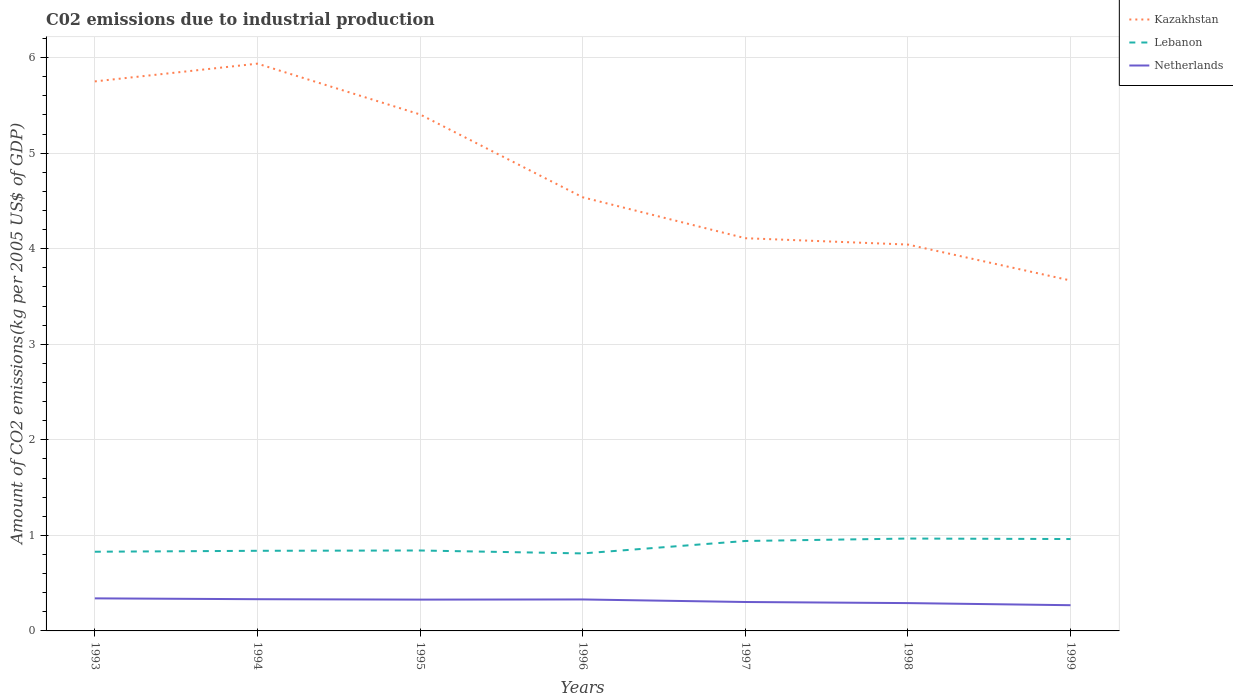How many different coloured lines are there?
Offer a terse response. 3. Does the line corresponding to Lebanon intersect with the line corresponding to Netherlands?
Keep it short and to the point. No. Across all years, what is the maximum amount of CO2 emitted due to industrial production in Lebanon?
Your response must be concise. 0.81. In which year was the amount of CO2 emitted due to industrial production in Kazakhstan maximum?
Your response must be concise. 1999. What is the total amount of CO2 emitted due to industrial production in Lebanon in the graph?
Provide a succinct answer. -0.13. What is the difference between the highest and the second highest amount of CO2 emitted due to industrial production in Lebanon?
Your answer should be compact. 0.16. Are the values on the major ticks of Y-axis written in scientific E-notation?
Provide a short and direct response. No. Does the graph contain any zero values?
Provide a short and direct response. No. Where does the legend appear in the graph?
Make the answer very short. Top right. How many legend labels are there?
Provide a short and direct response. 3. What is the title of the graph?
Your response must be concise. C02 emissions due to industrial production. What is the label or title of the Y-axis?
Offer a very short reply. Amount of CO2 emissions(kg per 2005 US$ of GDP). What is the Amount of CO2 emissions(kg per 2005 US$ of GDP) of Kazakhstan in 1993?
Make the answer very short. 5.75. What is the Amount of CO2 emissions(kg per 2005 US$ of GDP) of Lebanon in 1993?
Offer a terse response. 0.83. What is the Amount of CO2 emissions(kg per 2005 US$ of GDP) in Netherlands in 1993?
Keep it short and to the point. 0.34. What is the Amount of CO2 emissions(kg per 2005 US$ of GDP) in Kazakhstan in 1994?
Provide a short and direct response. 5.94. What is the Amount of CO2 emissions(kg per 2005 US$ of GDP) of Lebanon in 1994?
Offer a very short reply. 0.84. What is the Amount of CO2 emissions(kg per 2005 US$ of GDP) in Netherlands in 1994?
Keep it short and to the point. 0.33. What is the Amount of CO2 emissions(kg per 2005 US$ of GDP) in Kazakhstan in 1995?
Your answer should be very brief. 5.4. What is the Amount of CO2 emissions(kg per 2005 US$ of GDP) in Lebanon in 1995?
Your answer should be compact. 0.84. What is the Amount of CO2 emissions(kg per 2005 US$ of GDP) of Netherlands in 1995?
Give a very brief answer. 0.33. What is the Amount of CO2 emissions(kg per 2005 US$ of GDP) of Kazakhstan in 1996?
Your answer should be compact. 4.54. What is the Amount of CO2 emissions(kg per 2005 US$ of GDP) in Lebanon in 1996?
Give a very brief answer. 0.81. What is the Amount of CO2 emissions(kg per 2005 US$ of GDP) of Netherlands in 1996?
Make the answer very short. 0.33. What is the Amount of CO2 emissions(kg per 2005 US$ of GDP) in Kazakhstan in 1997?
Your answer should be compact. 4.11. What is the Amount of CO2 emissions(kg per 2005 US$ of GDP) in Lebanon in 1997?
Provide a succinct answer. 0.94. What is the Amount of CO2 emissions(kg per 2005 US$ of GDP) of Netherlands in 1997?
Make the answer very short. 0.3. What is the Amount of CO2 emissions(kg per 2005 US$ of GDP) in Kazakhstan in 1998?
Your response must be concise. 4.04. What is the Amount of CO2 emissions(kg per 2005 US$ of GDP) in Lebanon in 1998?
Provide a short and direct response. 0.97. What is the Amount of CO2 emissions(kg per 2005 US$ of GDP) of Netherlands in 1998?
Provide a short and direct response. 0.29. What is the Amount of CO2 emissions(kg per 2005 US$ of GDP) in Kazakhstan in 1999?
Give a very brief answer. 3.67. What is the Amount of CO2 emissions(kg per 2005 US$ of GDP) of Lebanon in 1999?
Your answer should be very brief. 0.96. What is the Amount of CO2 emissions(kg per 2005 US$ of GDP) in Netherlands in 1999?
Your answer should be compact. 0.27. Across all years, what is the maximum Amount of CO2 emissions(kg per 2005 US$ of GDP) in Kazakhstan?
Provide a short and direct response. 5.94. Across all years, what is the maximum Amount of CO2 emissions(kg per 2005 US$ of GDP) of Lebanon?
Your answer should be very brief. 0.97. Across all years, what is the maximum Amount of CO2 emissions(kg per 2005 US$ of GDP) of Netherlands?
Provide a succinct answer. 0.34. Across all years, what is the minimum Amount of CO2 emissions(kg per 2005 US$ of GDP) in Kazakhstan?
Your response must be concise. 3.67. Across all years, what is the minimum Amount of CO2 emissions(kg per 2005 US$ of GDP) in Lebanon?
Your answer should be compact. 0.81. Across all years, what is the minimum Amount of CO2 emissions(kg per 2005 US$ of GDP) of Netherlands?
Your answer should be compact. 0.27. What is the total Amount of CO2 emissions(kg per 2005 US$ of GDP) of Kazakhstan in the graph?
Your response must be concise. 33.45. What is the total Amount of CO2 emissions(kg per 2005 US$ of GDP) of Lebanon in the graph?
Provide a succinct answer. 6.19. What is the total Amount of CO2 emissions(kg per 2005 US$ of GDP) of Netherlands in the graph?
Give a very brief answer. 2.19. What is the difference between the Amount of CO2 emissions(kg per 2005 US$ of GDP) of Kazakhstan in 1993 and that in 1994?
Provide a short and direct response. -0.19. What is the difference between the Amount of CO2 emissions(kg per 2005 US$ of GDP) in Lebanon in 1993 and that in 1994?
Provide a succinct answer. -0.01. What is the difference between the Amount of CO2 emissions(kg per 2005 US$ of GDP) in Netherlands in 1993 and that in 1994?
Keep it short and to the point. 0.01. What is the difference between the Amount of CO2 emissions(kg per 2005 US$ of GDP) in Kazakhstan in 1993 and that in 1995?
Provide a short and direct response. 0.35. What is the difference between the Amount of CO2 emissions(kg per 2005 US$ of GDP) in Lebanon in 1993 and that in 1995?
Provide a short and direct response. -0.01. What is the difference between the Amount of CO2 emissions(kg per 2005 US$ of GDP) in Netherlands in 1993 and that in 1995?
Keep it short and to the point. 0.01. What is the difference between the Amount of CO2 emissions(kg per 2005 US$ of GDP) of Kazakhstan in 1993 and that in 1996?
Your answer should be very brief. 1.21. What is the difference between the Amount of CO2 emissions(kg per 2005 US$ of GDP) of Lebanon in 1993 and that in 1996?
Provide a succinct answer. 0.02. What is the difference between the Amount of CO2 emissions(kg per 2005 US$ of GDP) of Netherlands in 1993 and that in 1996?
Make the answer very short. 0.01. What is the difference between the Amount of CO2 emissions(kg per 2005 US$ of GDP) in Kazakhstan in 1993 and that in 1997?
Make the answer very short. 1.64. What is the difference between the Amount of CO2 emissions(kg per 2005 US$ of GDP) in Lebanon in 1993 and that in 1997?
Provide a short and direct response. -0.11. What is the difference between the Amount of CO2 emissions(kg per 2005 US$ of GDP) in Netherlands in 1993 and that in 1997?
Your response must be concise. 0.04. What is the difference between the Amount of CO2 emissions(kg per 2005 US$ of GDP) in Kazakhstan in 1993 and that in 1998?
Your answer should be very brief. 1.71. What is the difference between the Amount of CO2 emissions(kg per 2005 US$ of GDP) in Lebanon in 1993 and that in 1998?
Make the answer very short. -0.14. What is the difference between the Amount of CO2 emissions(kg per 2005 US$ of GDP) in Netherlands in 1993 and that in 1998?
Offer a terse response. 0.05. What is the difference between the Amount of CO2 emissions(kg per 2005 US$ of GDP) in Kazakhstan in 1993 and that in 1999?
Keep it short and to the point. 2.08. What is the difference between the Amount of CO2 emissions(kg per 2005 US$ of GDP) of Lebanon in 1993 and that in 1999?
Provide a short and direct response. -0.13. What is the difference between the Amount of CO2 emissions(kg per 2005 US$ of GDP) in Netherlands in 1993 and that in 1999?
Provide a succinct answer. 0.07. What is the difference between the Amount of CO2 emissions(kg per 2005 US$ of GDP) in Kazakhstan in 1994 and that in 1995?
Your answer should be compact. 0.53. What is the difference between the Amount of CO2 emissions(kg per 2005 US$ of GDP) in Lebanon in 1994 and that in 1995?
Your answer should be compact. -0. What is the difference between the Amount of CO2 emissions(kg per 2005 US$ of GDP) of Netherlands in 1994 and that in 1995?
Make the answer very short. 0. What is the difference between the Amount of CO2 emissions(kg per 2005 US$ of GDP) of Kazakhstan in 1994 and that in 1996?
Your answer should be very brief. 1.4. What is the difference between the Amount of CO2 emissions(kg per 2005 US$ of GDP) in Lebanon in 1994 and that in 1996?
Offer a terse response. 0.03. What is the difference between the Amount of CO2 emissions(kg per 2005 US$ of GDP) in Netherlands in 1994 and that in 1996?
Make the answer very short. 0. What is the difference between the Amount of CO2 emissions(kg per 2005 US$ of GDP) of Kazakhstan in 1994 and that in 1997?
Your answer should be compact. 1.83. What is the difference between the Amount of CO2 emissions(kg per 2005 US$ of GDP) in Lebanon in 1994 and that in 1997?
Provide a succinct answer. -0.1. What is the difference between the Amount of CO2 emissions(kg per 2005 US$ of GDP) of Netherlands in 1994 and that in 1997?
Your answer should be very brief. 0.03. What is the difference between the Amount of CO2 emissions(kg per 2005 US$ of GDP) in Kazakhstan in 1994 and that in 1998?
Give a very brief answer. 1.89. What is the difference between the Amount of CO2 emissions(kg per 2005 US$ of GDP) in Lebanon in 1994 and that in 1998?
Give a very brief answer. -0.13. What is the difference between the Amount of CO2 emissions(kg per 2005 US$ of GDP) in Netherlands in 1994 and that in 1998?
Provide a succinct answer. 0.04. What is the difference between the Amount of CO2 emissions(kg per 2005 US$ of GDP) in Kazakhstan in 1994 and that in 1999?
Your response must be concise. 2.27. What is the difference between the Amount of CO2 emissions(kg per 2005 US$ of GDP) of Lebanon in 1994 and that in 1999?
Ensure brevity in your answer.  -0.12. What is the difference between the Amount of CO2 emissions(kg per 2005 US$ of GDP) in Netherlands in 1994 and that in 1999?
Make the answer very short. 0.06. What is the difference between the Amount of CO2 emissions(kg per 2005 US$ of GDP) of Kazakhstan in 1995 and that in 1996?
Offer a very short reply. 0.87. What is the difference between the Amount of CO2 emissions(kg per 2005 US$ of GDP) of Lebanon in 1995 and that in 1996?
Provide a succinct answer. 0.03. What is the difference between the Amount of CO2 emissions(kg per 2005 US$ of GDP) in Netherlands in 1995 and that in 1996?
Provide a short and direct response. -0. What is the difference between the Amount of CO2 emissions(kg per 2005 US$ of GDP) of Kazakhstan in 1995 and that in 1997?
Ensure brevity in your answer.  1.29. What is the difference between the Amount of CO2 emissions(kg per 2005 US$ of GDP) of Lebanon in 1995 and that in 1997?
Offer a very short reply. -0.1. What is the difference between the Amount of CO2 emissions(kg per 2005 US$ of GDP) in Netherlands in 1995 and that in 1997?
Provide a short and direct response. 0.03. What is the difference between the Amount of CO2 emissions(kg per 2005 US$ of GDP) of Kazakhstan in 1995 and that in 1998?
Give a very brief answer. 1.36. What is the difference between the Amount of CO2 emissions(kg per 2005 US$ of GDP) in Lebanon in 1995 and that in 1998?
Make the answer very short. -0.12. What is the difference between the Amount of CO2 emissions(kg per 2005 US$ of GDP) of Netherlands in 1995 and that in 1998?
Your answer should be very brief. 0.04. What is the difference between the Amount of CO2 emissions(kg per 2005 US$ of GDP) of Kazakhstan in 1995 and that in 1999?
Keep it short and to the point. 1.74. What is the difference between the Amount of CO2 emissions(kg per 2005 US$ of GDP) in Lebanon in 1995 and that in 1999?
Offer a very short reply. -0.12. What is the difference between the Amount of CO2 emissions(kg per 2005 US$ of GDP) of Netherlands in 1995 and that in 1999?
Make the answer very short. 0.06. What is the difference between the Amount of CO2 emissions(kg per 2005 US$ of GDP) of Kazakhstan in 1996 and that in 1997?
Your response must be concise. 0.43. What is the difference between the Amount of CO2 emissions(kg per 2005 US$ of GDP) of Lebanon in 1996 and that in 1997?
Offer a terse response. -0.13. What is the difference between the Amount of CO2 emissions(kg per 2005 US$ of GDP) of Netherlands in 1996 and that in 1997?
Your answer should be very brief. 0.03. What is the difference between the Amount of CO2 emissions(kg per 2005 US$ of GDP) in Kazakhstan in 1996 and that in 1998?
Your response must be concise. 0.49. What is the difference between the Amount of CO2 emissions(kg per 2005 US$ of GDP) in Lebanon in 1996 and that in 1998?
Provide a short and direct response. -0.16. What is the difference between the Amount of CO2 emissions(kg per 2005 US$ of GDP) of Netherlands in 1996 and that in 1998?
Ensure brevity in your answer.  0.04. What is the difference between the Amount of CO2 emissions(kg per 2005 US$ of GDP) of Kazakhstan in 1996 and that in 1999?
Your answer should be compact. 0.87. What is the difference between the Amount of CO2 emissions(kg per 2005 US$ of GDP) in Lebanon in 1996 and that in 1999?
Make the answer very short. -0.15. What is the difference between the Amount of CO2 emissions(kg per 2005 US$ of GDP) in Netherlands in 1996 and that in 1999?
Keep it short and to the point. 0.06. What is the difference between the Amount of CO2 emissions(kg per 2005 US$ of GDP) of Kazakhstan in 1997 and that in 1998?
Ensure brevity in your answer.  0.07. What is the difference between the Amount of CO2 emissions(kg per 2005 US$ of GDP) of Lebanon in 1997 and that in 1998?
Ensure brevity in your answer.  -0.03. What is the difference between the Amount of CO2 emissions(kg per 2005 US$ of GDP) of Netherlands in 1997 and that in 1998?
Keep it short and to the point. 0.01. What is the difference between the Amount of CO2 emissions(kg per 2005 US$ of GDP) in Kazakhstan in 1997 and that in 1999?
Provide a succinct answer. 0.44. What is the difference between the Amount of CO2 emissions(kg per 2005 US$ of GDP) in Lebanon in 1997 and that in 1999?
Offer a very short reply. -0.02. What is the difference between the Amount of CO2 emissions(kg per 2005 US$ of GDP) in Netherlands in 1997 and that in 1999?
Offer a terse response. 0.03. What is the difference between the Amount of CO2 emissions(kg per 2005 US$ of GDP) in Kazakhstan in 1998 and that in 1999?
Offer a terse response. 0.38. What is the difference between the Amount of CO2 emissions(kg per 2005 US$ of GDP) in Lebanon in 1998 and that in 1999?
Make the answer very short. 0.01. What is the difference between the Amount of CO2 emissions(kg per 2005 US$ of GDP) in Netherlands in 1998 and that in 1999?
Offer a terse response. 0.02. What is the difference between the Amount of CO2 emissions(kg per 2005 US$ of GDP) of Kazakhstan in 1993 and the Amount of CO2 emissions(kg per 2005 US$ of GDP) of Lebanon in 1994?
Your answer should be very brief. 4.91. What is the difference between the Amount of CO2 emissions(kg per 2005 US$ of GDP) of Kazakhstan in 1993 and the Amount of CO2 emissions(kg per 2005 US$ of GDP) of Netherlands in 1994?
Provide a succinct answer. 5.42. What is the difference between the Amount of CO2 emissions(kg per 2005 US$ of GDP) in Lebanon in 1993 and the Amount of CO2 emissions(kg per 2005 US$ of GDP) in Netherlands in 1994?
Your answer should be very brief. 0.5. What is the difference between the Amount of CO2 emissions(kg per 2005 US$ of GDP) in Kazakhstan in 1993 and the Amount of CO2 emissions(kg per 2005 US$ of GDP) in Lebanon in 1995?
Your answer should be very brief. 4.91. What is the difference between the Amount of CO2 emissions(kg per 2005 US$ of GDP) of Kazakhstan in 1993 and the Amount of CO2 emissions(kg per 2005 US$ of GDP) of Netherlands in 1995?
Provide a short and direct response. 5.42. What is the difference between the Amount of CO2 emissions(kg per 2005 US$ of GDP) of Lebanon in 1993 and the Amount of CO2 emissions(kg per 2005 US$ of GDP) of Netherlands in 1995?
Keep it short and to the point. 0.5. What is the difference between the Amount of CO2 emissions(kg per 2005 US$ of GDP) of Kazakhstan in 1993 and the Amount of CO2 emissions(kg per 2005 US$ of GDP) of Lebanon in 1996?
Your answer should be compact. 4.94. What is the difference between the Amount of CO2 emissions(kg per 2005 US$ of GDP) of Kazakhstan in 1993 and the Amount of CO2 emissions(kg per 2005 US$ of GDP) of Netherlands in 1996?
Make the answer very short. 5.42. What is the difference between the Amount of CO2 emissions(kg per 2005 US$ of GDP) of Lebanon in 1993 and the Amount of CO2 emissions(kg per 2005 US$ of GDP) of Netherlands in 1996?
Give a very brief answer. 0.5. What is the difference between the Amount of CO2 emissions(kg per 2005 US$ of GDP) in Kazakhstan in 1993 and the Amount of CO2 emissions(kg per 2005 US$ of GDP) in Lebanon in 1997?
Keep it short and to the point. 4.81. What is the difference between the Amount of CO2 emissions(kg per 2005 US$ of GDP) of Kazakhstan in 1993 and the Amount of CO2 emissions(kg per 2005 US$ of GDP) of Netherlands in 1997?
Provide a short and direct response. 5.45. What is the difference between the Amount of CO2 emissions(kg per 2005 US$ of GDP) of Lebanon in 1993 and the Amount of CO2 emissions(kg per 2005 US$ of GDP) of Netherlands in 1997?
Keep it short and to the point. 0.53. What is the difference between the Amount of CO2 emissions(kg per 2005 US$ of GDP) in Kazakhstan in 1993 and the Amount of CO2 emissions(kg per 2005 US$ of GDP) in Lebanon in 1998?
Your response must be concise. 4.78. What is the difference between the Amount of CO2 emissions(kg per 2005 US$ of GDP) of Kazakhstan in 1993 and the Amount of CO2 emissions(kg per 2005 US$ of GDP) of Netherlands in 1998?
Give a very brief answer. 5.46. What is the difference between the Amount of CO2 emissions(kg per 2005 US$ of GDP) of Lebanon in 1993 and the Amount of CO2 emissions(kg per 2005 US$ of GDP) of Netherlands in 1998?
Provide a short and direct response. 0.54. What is the difference between the Amount of CO2 emissions(kg per 2005 US$ of GDP) in Kazakhstan in 1993 and the Amount of CO2 emissions(kg per 2005 US$ of GDP) in Lebanon in 1999?
Keep it short and to the point. 4.79. What is the difference between the Amount of CO2 emissions(kg per 2005 US$ of GDP) of Kazakhstan in 1993 and the Amount of CO2 emissions(kg per 2005 US$ of GDP) of Netherlands in 1999?
Offer a terse response. 5.48. What is the difference between the Amount of CO2 emissions(kg per 2005 US$ of GDP) of Lebanon in 1993 and the Amount of CO2 emissions(kg per 2005 US$ of GDP) of Netherlands in 1999?
Your answer should be compact. 0.56. What is the difference between the Amount of CO2 emissions(kg per 2005 US$ of GDP) in Kazakhstan in 1994 and the Amount of CO2 emissions(kg per 2005 US$ of GDP) in Lebanon in 1995?
Your answer should be very brief. 5.09. What is the difference between the Amount of CO2 emissions(kg per 2005 US$ of GDP) of Kazakhstan in 1994 and the Amount of CO2 emissions(kg per 2005 US$ of GDP) of Netherlands in 1995?
Your answer should be very brief. 5.61. What is the difference between the Amount of CO2 emissions(kg per 2005 US$ of GDP) of Lebanon in 1994 and the Amount of CO2 emissions(kg per 2005 US$ of GDP) of Netherlands in 1995?
Give a very brief answer. 0.51. What is the difference between the Amount of CO2 emissions(kg per 2005 US$ of GDP) of Kazakhstan in 1994 and the Amount of CO2 emissions(kg per 2005 US$ of GDP) of Lebanon in 1996?
Offer a terse response. 5.13. What is the difference between the Amount of CO2 emissions(kg per 2005 US$ of GDP) in Kazakhstan in 1994 and the Amount of CO2 emissions(kg per 2005 US$ of GDP) in Netherlands in 1996?
Keep it short and to the point. 5.61. What is the difference between the Amount of CO2 emissions(kg per 2005 US$ of GDP) of Lebanon in 1994 and the Amount of CO2 emissions(kg per 2005 US$ of GDP) of Netherlands in 1996?
Ensure brevity in your answer.  0.51. What is the difference between the Amount of CO2 emissions(kg per 2005 US$ of GDP) in Kazakhstan in 1994 and the Amount of CO2 emissions(kg per 2005 US$ of GDP) in Lebanon in 1997?
Ensure brevity in your answer.  5. What is the difference between the Amount of CO2 emissions(kg per 2005 US$ of GDP) of Kazakhstan in 1994 and the Amount of CO2 emissions(kg per 2005 US$ of GDP) of Netherlands in 1997?
Provide a short and direct response. 5.63. What is the difference between the Amount of CO2 emissions(kg per 2005 US$ of GDP) of Lebanon in 1994 and the Amount of CO2 emissions(kg per 2005 US$ of GDP) of Netherlands in 1997?
Give a very brief answer. 0.54. What is the difference between the Amount of CO2 emissions(kg per 2005 US$ of GDP) of Kazakhstan in 1994 and the Amount of CO2 emissions(kg per 2005 US$ of GDP) of Lebanon in 1998?
Give a very brief answer. 4.97. What is the difference between the Amount of CO2 emissions(kg per 2005 US$ of GDP) in Kazakhstan in 1994 and the Amount of CO2 emissions(kg per 2005 US$ of GDP) in Netherlands in 1998?
Give a very brief answer. 5.65. What is the difference between the Amount of CO2 emissions(kg per 2005 US$ of GDP) in Lebanon in 1994 and the Amount of CO2 emissions(kg per 2005 US$ of GDP) in Netherlands in 1998?
Your answer should be compact. 0.55. What is the difference between the Amount of CO2 emissions(kg per 2005 US$ of GDP) in Kazakhstan in 1994 and the Amount of CO2 emissions(kg per 2005 US$ of GDP) in Lebanon in 1999?
Your answer should be compact. 4.97. What is the difference between the Amount of CO2 emissions(kg per 2005 US$ of GDP) of Kazakhstan in 1994 and the Amount of CO2 emissions(kg per 2005 US$ of GDP) of Netherlands in 1999?
Provide a succinct answer. 5.67. What is the difference between the Amount of CO2 emissions(kg per 2005 US$ of GDP) in Lebanon in 1994 and the Amount of CO2 emissions(kg per 2005 US$ of GDP) in Netherlands in 1999?
Your answer should be very brief. 0.57. What is the difference between the Amount of CO2 emissions(kg per 2005 US$ of GDP) in Kazakhstan in 1995 and the Amount of CO2 emissions(kg per 2005 US$ of GDP) in Lebanon in 1996?
Provide a succinct answer. 4.59. What is the difference between the Amount of CO2 emissions(kg per 2005 US$ of GDP) of Kazakhstan in 1995 and the Amount of CO2 emissions(kg per 2005 US$ of GDP) of Netherlands in 1996?
Your answer should be compact. 5.08. What is the difference between the Amount of CO2 emissions(kg per 2005 US$ of GDP) in Lebanon in 1995 and the Amount of CO2 emissions(kg per 2005 US$ of GDP) in Netherlands in 1996?
Ensure brevity in your answer.  0.51. What is the difference between the Amount of CO2 emissions(kg per 2005 US$ of GDP) in Kazakhstan in 1995 and the Amount of CO2 emissions(kg per 2005 US$ of GDP) in Lebanon in 1997?
Offer a terse response. 4.46. What is the difference between the Amount of CO2 emissions(kg per 2005 US$ of GDP) in Kazakhstan in 1995 and the Amount of CO2 emissions(kg per 2005 US$ of GDP) in Netherlands in 1997?
Make the answer very short. 5.1. What is the difference between the Amount of CO2 emissions(kg per 2005 US$ of GDP) in Lebanon in 1995 and the Amount of CO2 emissions(kg per 2005 US$ of GDP) in Netherlands in 1997?
Ensure brevity in your answer.  0.54. What is the difference between the Amount of CO2 emissions(kg per 2005 US$ of GDP) in Kazakhstan in 1995 and the Amount of CO2 emissions(kg per 2005 US$ of GDP) in Lebanon in 1998?
Provide a short and direct response. 4.44. What is the difference between the Amount of CO2 emissions(kg per 2005 US$ of GDP) of Kazakhstan in 1995 and the Amount of CO2 emissions(kg per 2005 US$ of GDP) of Netherlands in 1998?
Make the answer very short. 5.11. What is the difference between the Amount of CO2 emissions(kg per 2005 US$ of GDP) in Lebanon in 1995 and the Amount of CO2 emissions(kg per 2005 US$ of GDP) in Netherlands in 1998?
Your response must be concise. 0.55. What is the difference between the Amount of CO2 emissions(kg per 2005 US$ of GDP) of Kazakhstan in 1995 and the Amount of CO2 emissions(kg per 2005 US$ of GDP) of Lebanon in 1999?
Make the answer very short. 4.44. What is the difference between the Amount of CO2 emissions(kg per 2005 US$ of GDP) of Kazakhstan in 1995 and the Amount of CO2 emissions(kg per 2005 US$ of GDP) of Netherlands in 1999?
Your answer should be compact. 5.14. What is the difference between the Amount of CO2 emissions(kg per 2005 US$ of GDP) of Lebanon in 1995 and the Amount of CO2 emissions(kg per 2005 US$ of GDP) of Netherlands in 1999?
Offer a very short reply. 0.57. What is the difference between the Amount of CO2 emissions(kg per 2005 US$ of GDP) in Kazakhstan in 1996 and the Amount of CO2 emissions(kg per 2005 US$ of GDP) in Lebanon in 1997?
Your response must be concise. 3.6. What is the difference between the Amount of CO2 emissions(kg per 2005 US$ of GDP) in Kazakhstan in 1996 and the Amount of CO2 emissions(kg per 2005 US$ of GDP) in Netherlands in 1997?
Your response must be concise. 4.24. What is the difference between the Amount of CO2 emissions(kg per 2005 US$ of GDP) in Lebanon in 1996 and the Amount of CO2 emissions(kg per 2005 US$ of GDP) in Netherlands in 1997?
Ensure brevity in your answer.  0.51. What is the difference between the Amount of CO2 emissions(kg per 2005 US$ of GDP) of Kazakhstan in 1996 and the Amount of CO2 emissions(kg per 2005 US$ of GDP) of Lebanon in 1998?
Keep it short and to the point. 3.57. What is the difference between the Amount of CO2 emissions(kg per 2005 US$ of GDP) of Kazakhstan in 1996 and the Amount of CO2 emissions(kg per 2005 US$ of GDP) of Netherlands in 1998?
Provide a short and direct response. 4.25. What is the difference between the Amount of CO2 emissions(kg per 2005 US$ of GDP) of Lebanon in 1996 and the Amount of CO2 emissions(kg per 2005 US$ of GDP) of Netherlands in 1998?
Your answer should be very brief. 0.52. What is the difference between the Amount of CO2 emissions(kg per 2005 US$ of GDP) in Kazakhstan in 1996 and the Amount of CO2 emissions(kg per 2005 US$ of GDP) in Lebanon in 1999?
Ensure brevity in your answer.  3.58. What is the difference between the Amount of CO2 emissions(kg per 2005 US$ of GDP) in Kazakhstan in 1996 and the Amount of CO2 emissions(kg per 2005 US$ of GDP) in Netherlands in 1999?
Ensure brevity in your answer.  4.27. What is the difference between the Amount of CO2 emissions(kg per 2005 US$ of GDP) of Lebanon in 1996 and the Amount of CO2 emissions(kg per 2005 US$ of GDP) of Netherlands in 1999?
Your answer should be compact. 0.54. What is the difference between the Amount of CO2 emissions(kg per 2005 US$ of GDP) of Kazakhstan in 1997 and the Amount of CO2 emissions(kg per 2005 US$ of GDP) of Lebanon in 1998?
Your answer should be compact. 3.14. What is the difference between the Amount of CO2 emissions(kg per 2005 US$ of GDP) of Kazakhstan in 1997 and the Amount of CO2 emissions(kg per 2005 US$ of GDP) of Netherlands in 1998?
Give a very brief answer. 3.82. What is the difference between the Amount of CO2 emissions(kg per 2005 US$ of GDP) of Lebanon in 1997 and the Amount of CO2 emissions(kg per 2005 US$ of GDP) of Netherlands in 1998?
Your response must be concise. 0.65. What is the difference between the Amount of CO2 emissions(kg per 2005 US$ of GDP) of Kazakhstan in 1997 and the Amount of CO2 emissions(kg per 2005 US$ of GDP) of Lebanon in 1999?
Your response must be concise. 3.15. What is the difference between the Amount of CO2 emissions(kg per 2005 US$ of GDP) in Kazakhstan in 1997 and the Amount of CO2 emissions(kg per 2005 US$ of GDP) in Netherlands in 1999?
Ensure brevity in your answer.  3.84. What is the difference between the Amount of CO2 emissions(kg per 2005 US$ of GDP) of Lebanon in 1997 and the Amount of CO2 emissions(kg per 2005 US$ of GDP) of Netherlands in 1999?
Give a very brief answer. 0.67. What is the difference between the Amount of CO2 emissions(kg per 2005 US$ of GDP) in Kazakhstan in 1998 and the Amount of CO2 emissions(kg per 2005 US$ of GDP) in Lebanon in 1999?
Ensure brevity in your answer.  3.08. What is the difference between the Amount of CO2 emissions(kg per 2005 US$ of GDP) in Kazakhstan in 1998 and the Amount of CO2 emissions(kg per 2005 US$ of GDP) in Netherlands in 1999?
Ensure brevity in your answer.  3.77. What is the difference between the Amount of CO2 emissions(kg per 2005 US$ of GDP) in Lebanon in 1998 and the Amount of CO2 emissions(kg per 2005 US$ of GDP) in Netherlands in 1999?
Keep it short and to the point. 0.7. What is the average Amount of CO2 emissions(kg per 2005 US$ of GDP) of Kazakhstan per year?
Your answer should be very brief. 4.78. What is the average Amount of CO2 emissions(kg per 2005 US$ of GDP) in Lebanon per year?
Ensure brevity in your answer.  0.88. What is the average Amount of CO2 emissions(kg per 2005 US$ of GDP) in Netherlands per year?
Ensure brevity in your answer.  0.31. In the year 1993, what is the difference between the Amount of CO2 emissions(kg per 2005 US$ of GDP) in Kazakhstan and Amount of CO2 emissions(kg per 2005 US$ of GDP) in Lebanon?
Your answer should be compact. 4.92. In the year 1993, what is the difference between the Amount of CO2 emissions(kg per 2005 US$ of GDP) in Kazakhstan and Amount of CO2 emissions(kg per 2005 US$ of GDP) in Netherlands?
Provide a succinct answer. 5.41. In the year 1993, what is the difference between the Amount of CO2 emissions(kg per 2005 US$ of GDP) of Lebanon and Amount of CO2 emissions(kg per 2005 US$ of GDP) of Netherlands?
Provide a succinct answer. 0.49. In the year 1994, what is the difference between the Amount of CO2 emissions(kg per 2005 US$ of GDP) in Kazakhstan and Amount of CO2 emissions(kg per 2005 US$ of GDP) in Lebanon?
Your response must be concise. 5.1. In the year 1994, what is the difference between the Amount of CO2 emissions(kg per 2005 US$ of GDP) in Kazakhstan and Amount of CO2 emissions(kg per 2005 US$ of GDP) in Netherlands?
Provide a succinct answer. 5.6. In the year 1994, what is the difference between the Amount of CO2 emissions(kg per 2005 US$ of GDP) of Lebanon and Amount of CO2 emissions(kg per 2005 US$ of GDP) of Netherlands?
Provide a succinct answer. 0.51. In the year 1995, what is the difference between the Amount of CO2 emissions(kg per 2005 US$ of GDP) in Kazakhstan and Amount of CO2 emissions(kg per 2005 US$ of GDP) in Lebanon?
Keep it short and to the point. 4.56. In the year 1995, what is the difference between the Amount of CO2 emissions(kg per 2005 US$ of GDP) of Kazakhstan and Amount of CO2 emissions(kg per 2005 US$ of GDP) of Netherlands?
Your response must be concise. 5.08. In the year 1995, what is the difference between the Amount of CO2 emissions(kg per 2005 US$ of GDP) of Lebanon and Amount of CO2 emissions(kg per 2005 US$ of GDP) of Netherlands?
Offer a terse response. 0.51. In the year 1996, what is the difference between the Amount of CO2 emissions(kg per 2005 US$ of GDP) in Kazakhstan and Amount of CO2 emissions(kg per 2005 US$ of GDP) in Lebanon?
Provide a succinct answer. 3.73. In the year 1996, what is the difference between the Amount of CO2 emissions(kg per 2005 US$ of GDP) of Kazakhstan and Amount of CO2 emissions(kg per 2005 US$ of GDP) of Netherlands?
Your answer should be very brief. 4.21. In the year 1996, what is the difference between the Amount of CO2 emissions(kg per 2005 US$ of GDP) of Lebanon and Amount of CO2 emissions(kg per 2005 US$ of GDP) of Netherlands?
Provide a short and direct response. 0.48. In the year 1997, what is the difference between the Amount of CO2 emissions(kg per 2005 US$ of GDP) of Kazakhstan and Amount of CO2 emissions(kg per 2005 US$ of GDP) of Lebanon?
Give a very brief answer. 3.17. In the year 1997, what is the difference between the Amount of CO2 emissions(kg per 2005 US$ of GDP) of Kazakhstan and Amount of CO2 emissions(kg per 2005 US$ of GDP) of Netherlands?
Offer a very short reply. 3.81. In the year 1997, what is the difference between the Amount of CO2 emissions(kg per 2005 US$ of GDP) in Lebanon and Amount of CO2 emissions(kg per 2005 US$ of GDP) in Netherlands?
Ensure brevity in your answer.  0.64. In the year 1998, what is the difference between the Amount of CO2 emissions(kg per 2005 US$ of GDP) in Kazakhstan and Amount of CO2 emissions(kg per 2005 US$ of GDP) in Lebanon?
Offer a terse response. 3.08. In the year 1998, what is the difference between the Amount of CO2 emissions(kg per 2005 US$ of GDP) of Kazakhstan and Amount of CO2 emissions(kg per 2005 US$ of GDP) of Netherlands?
Give a very brief answer. 3.75. In the year 1998, what is the difference between the Amount of CO2 emissions(kg per 2005 US$ of GDP) in Lebanon and Amount of CO2 emissions(kg per 2005 US$ of GDP) in Netherlands?
Your response must be concise. 0.68. In the year 1999, what is the difference between the Amount of CO2 emissions(kg per 2005 US$ of GDP) of Kazakhstan and Amount of CO2 emissions(kg per 2005 US$ of GDP) of Lebanon?
Offer a terse response. 2.71. In the year 1999, what is the difference between the Amount of CO2 emissions(kg per 2005 US$ of GDP) in Kazakhstan and Amount of CO2 emissions(kg per 2005 US$ of GDP) in Netherlands?
Keep it short and to the point. 3.4. In the year 1999, what is the difference between the Amount of CO2 emissions(kg per 2005 US$ of GDP) in Lebanon and Amount of CO2 emissions(kg per 2005 US$ of GDP) in Netherlands?
Keep it short and to the point. 0.69. What is the ratio of the Amount of CO2 emissions(kg per 2005 US$ of GDP) of Kazakhstan in 1993 to that in 1994?
Offer a very short reply. 0.97. What is the ratio of the Amount of CO2 emissions(kg per 2005 US$ of GDP) in Lebanon in 1993 to that in 1994?
Provide a short and direct response. 0.99. What is the ratio of the Amount of CO2 emissions(kg per 2005 US$ of GDP) of Netherlands in 1993 to that in 1994?
Offer a terse response. 1.03. What is the ratio of the Amount of CO2 emissions(kg per 2005 US$ of GDP) of Kazakhstan in 1993 to that in 1995?
Provide a succinct answer. 1.06. What is the ratio of the Amount of CO2 emissions(kg per 2005 US$ of GDP) of Lebanon in 1993 to that in 1995?
Provide a succinct answer. 0.98. What is the ratio of the Amount of CO2 emissions(kg per 2005 US$ of GDP) in Netherlands in 1993 to that in 1995?
Offer a very short reply. 1.04. What is the ratio of the Amount of CO2 emissions(kg per 2005 US$ of GDP) in Kazakhstan in 1993 to that in 1996?
Your answer should be compact. 1.27. What is the ratio of the Amount of CO2 emissions(kg per 2005 US$ of GDP) of Lebanon in 1993 to that in 1996?
Give a very brief answer. 1.02. What is the ratio of the Amount of CO2 emissions(kg per 2005 US$ of GDP) in Netherlands in 1993 to that in 1996?
Your response must be concise. 1.03. What is the ratio of the Amount of CO2 emissions(kg per 2005 US$ of GDP) of Kazakhstan in 1993 to that in 1997?
Offer a terse response. 1.4. What is the ratio of the Amount of CO2 emissions(kg per 2005 US$ of GDP) of Lebanon in 1993 to that in 1997?
Your answer should be very brief. 0.88. What is the ratio of the Amount of CO2 emissions(kg per 2005 US$ of GDP) of Netherlands in 1993 to that in 1997?
Your answer should be compact. 1.13. What is the ratio of the Amount of CO2 emissions(kg per 2005 US$ of GDP) in Kazakhstan in 1993 to that in 1998?
Your answer should be compact. 1.42. What is the ratio of the Amount of CO2 emissions(kg per 2005 US$ of GDP) of Lebanon in 1993 to that in 1998?
Provide a succinct answer. 0.86. What is the ratio of the Amount of CO2 emissions(kg per 2005 US$ of GDP) in Netherlands in 1993 to that in 1998?
Your answer should be compact. 1.17. What is the ratio of the Amount of CO2 emissions(kg per 2005 US$ of GDP) in Kazakhstan in 1993 to that in 1999?
Your response must be concise. 1.57. What is the ratio of the Amount of CO2 emissions(kg per 2005 US$ of GDP) in Lebanon in 1993 to that in 1999?
Make the answer very short. 0.86. What is the ratio of the Amount of CO2 emissions(kg per 2005 US$ of GDP) of Netherlands in 1993 to that in 1999?
Provide a short and direct response. 1.27. What is the ratio of the Amount of CO2 emissions(kg per 2005 US$ of GDP) in Kazakhstan in 1994 to that in 1995?
Your answer should be very brief. 1.1. What is the ratio of the Amount of CO2 emissions(kg per 2005 US$ of GDP) in Netherlands in 1994 to that in 1995?
Make the answer very short. 1.01. What is the ratio of the Amount of CO2 emissions(kg per 2005 US$ of GDP) of Kazakhstan in 1994 to that in 1996?
Your response must be concise. 1.31. What is the ratio of the Amount of CO2 emissions(kg per 2005 US$ of GDP) of Lebanon in 1994 to that in 1996?
Your response must be concise. 1.03. What is the ratio of the Amount of CO2 emissions(kg per 2005 US$ of GDP) in Netherlands in 1994 to that in 1996?
Provide a succinct answer. 1.01. What is the ratio of the Amount of CO2 emissions(kg per 2005 US$ of GDP) of Kazakhstan in 1994 to that in 1997?
Provide a short and direct response. 1.44. What is the ratio of the Amount of CO2 emissions(kg per 2005 US$ of GDP) of Lebanon in 1994 to that in 1997?
Give a very brief answer. 0.89. What is the ratio of the Amount of CO2 emissions(kg per 2005 US$ of GDP) in Netherlands in 1994 to that in 1997?
Your response must be concise. 1.1. What is the ratio of the Amount of CO2 emissions(kg per 2005 US$ of GDP) of Kazakhstan in 1994 to that in 1998?
Make the answer very short. 1.47. What is the ratio of the Amount of CO2 emissions(kg per 2005 US$ of GDP) in Lebanon in 1994 to that in 1998?
Keep it short and to the point. 0.87. What is the ratio of the Amount of CO2 emissions(kg per 2005 US$ of GDP) in Netherlands in 1994 to that in 1998?
Your response must be concise. 1.14. What is the ratio of the Amount of CO2 emissions(kg per 2005 US$ of GDP) in Kazakhstan in 1994 to that in 1999?
Make the answer very short. 1.62. What is the ratio of the Amount of CO2 emissions(kg per 2005 US$ of GDP) of Lebanon in 1994 to that in 1999?
Give a very brief answer. 0.87. What is the ratio of the Amount of CO2 emissions(kg per 2005 US$ of GDP) in Netherlands in 1994 to that in 1999?
Your answer should be compact. 1.23. What is the ratio of the Amount of CO2 emissions(kg per 2005 US$ of GDP) of Kazakhstan in 1995 to that in 1996?
Your answer should be compact. 1.19. What is the ratio of the Amount of CO2 emissions(kg per 2005 US$ of GDP) of Lebanon in 1995 to that in 1996?
Your answer should be very brief. 1.04. What is the ratio of the Amount of CO2 emissions(kg per 2005 US$ of GDP) in Kazakhstan in 1995 to that in 1997?
Your response must be concise. 1.32. What is the ratio of the Amount of CO2 emissions(kg per 2005 US$ of GDP) of Lebanon in 1995 to that in 1997?
Give a very brief answer. 0.89. What is the ratio of the Amount of CO2 emissions(kg per 2005 US$ of GDP) in Netherlands in 1995 to that in 1997?
Provide a succinct answer. 1.08. What is the ratio of the Amount of CO2 emissions(kg per 2005 US$ of GDP) in Kazakhstan in 1995 to that in 1998?
Keep it short and to the point. 1.34. What is the ratio of the Amount of CO2 emissions(kg per 2005 US$ of GDP) of Lebanon in 1995 to that in 1998?
Provide a succinct answer. 0.87. What is the ratio of the Amount of CO2 emissions(kg per 2005 US$ of GDP) of Netherlands in 1995 to that in 1998?
Offer a very short reply. 1.13. What is the ratio of the Amount of CO2 emissions(kg per 2005 US$ of GDP) in Kazakhstan in 1995 to that in 1999?
Make the answer very short. 1.47. What is the ratio of the Amount of CO2 emissions(kg per 2005 US$ of GDP) in Lebanon in 1995 to that in 1999?
Your answer should be very brief. 0.88. What is the ratio of the Amount of CO2 emissions(kg per 2005 US$ of GDP) in Netherlands in 1995 to that in 1999?
Make the answer very short. 1.22. What is the ratio of the Amount of CO2 emissions(kg per 2005 US$ of GDP) of Kazakhstan in 1996 to that in 1997?
Give a very brief answer. 1.1. What is the ratio of the Amount of CO2 emissions(kg per 2005 US$ of GDP) of Lebanon in 1996 to that in 1997?
Provide a short and direct response. 0.86. What is the ratio of the Amount of CO2 emissions(kg per 2005 US$ of GDP) of Netherlands in 1996 to that in 1997?
Offer a very short reply. 1.09. What is the ratio of the Amount of CO2 emissions(kg per 2005 US$ of GDP) of Kazakhstan in 1996 to that in 1998?
Give a very brief answer. 1.12. What is the ratio of the Amount of CO2 emissions(kg per 2005 US$ of GDP) of Lebanon in 1996 to that in 1998?
Ensure brevity in your answer.  0.84. What is the ratio of the Amount of CO2 emissions(kg per 2005 US$ of GDP) of Netherlands in 1996 to that in 1998?
Provide a succinct answer. 1.13. What is the ratio of the Amount of CO2 emissions(kg per 2005 US$ of GDP) in Kazakhstan in 1996 to that in 1999?
Give a very brief answer. 1.24. What is the ratio of the Amount of CO2 emissions(kg per 2005 US$ of GDP) in Lebanon in 1996 to that in 1999?
Provide a succinct answer. 0.84. What is the ratio of the Amount of CO2 emissions(kg per 2005 US$ of GDP) in Netherlands in 1996 to that in 1999?
Keep it short and to the point. 1.22. What is the ratio of the Amount of CO2 emissions(kg per 2005 US$ of GDP) in Kazakhstan in 1997 to that in 1998?
Ensure brevity in your answer.  1.02. What is the ratio of the Amount of CO2 emissions(kg per 2005 US$ of GDP) of Lebanon in 1997 to that in 1998?
Offer a terse response. 0.97. What is the ratio of the Amount of CO2 emissions(kg per 2005 US$ of GDP) of Netherlands in 1997 to that in 1998?
Provide a succinct answer. 1.04. What is the ratio of the Amount of CO2 emissions(kg per 2005 US$ of GDP) in Kazakhstan in 1997 to that in 1999?
Provide a succinct answer. 1.12. What is the ratio of the Amount of CO2 emissions(kg per 2005 US$ of GDP) of Lebanon in 1997 to that in 1999?
Your answer should be compact. 0.98. What is the ratio of the Amount of CO2 emissions(kg per 2005 US$ of GDP) in Netherlands in 1997 to that in 1999?
Ensure brevity in your answer.  1.12. What is the ratio of the Amount of CO2 emissions(kg per 2005 US$ of GDP) in Kazakhstan in 1998 to that in 1999?
Keep it short and to the point. 1.1. What is the ratio of the Amount of CO2 emissions(kg per 2005 US$ of GDP) in Lebanon in 1998 to that in 1999?
Ensure brevity in your answer.  1.01. What is the ratio of the Amount of CO2 emissions(kg per 2005 US$ of GDP) in Netherlands in 1998 to that in 1999?
Your response must be concise. 1.08. What is the difference between the highest and the second highest Amount of CO2 emissions(kg per 2005 US$ of GDP) in Kazakhstan?
Your answer should be very brief. 0.19. What is the difference between the highest and the second highest Amount of CO2 emissions(kg per 2005 US$ of GDP) of Lebanon?
Offer a terse response. 0.01. What is the difference between the highest and the second highest Amount of CO2 emissions(kg per 2005 US$ of GDP) of Netherlands?
Ensure brevity in your answer.  0.01. What is the difference between the highest and the lowest Amount of CO2 emissions(kg per 2005 US$ of GDP) in Kazakhstan?
Your response must be concise. 2.27. What is the difference between the highest and the lowest Amount of CO2 emissions(kg per 2005 US$ of GDP) of Lebanon?
Provide a succinct answer. 0.16. What is the difference between the highest and the lowest Amount of CO2 emissions(kg per 2005 US$ of GDP) of Netherlands?
Your response must be concise. 0.07. 